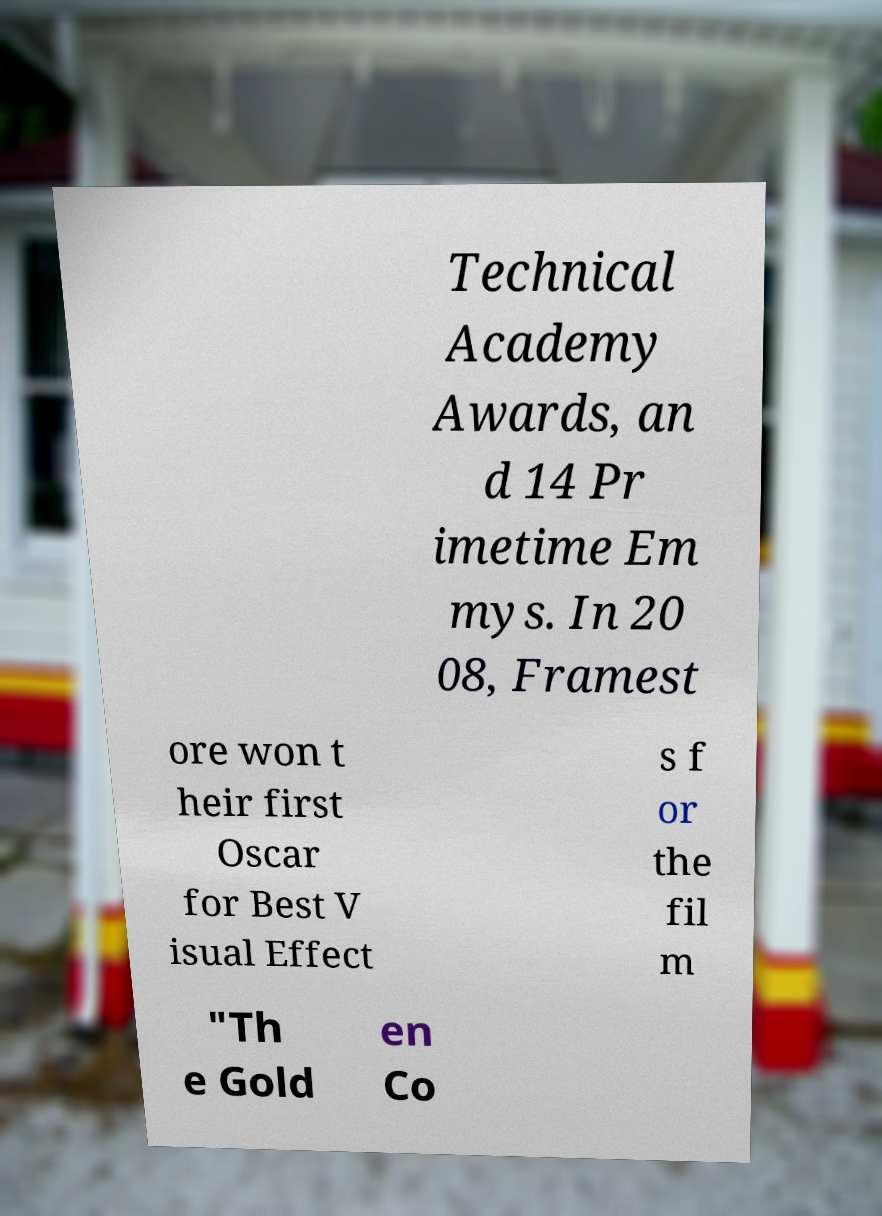I need the written content from this picture converted into text. Can you do that? Technical Academy Awards, an d 14 Pr imetime Em mys. In 20 08, Framest ore won t heir first Oscar for Best V isual Effect s f or the fil m "Th e Gold en Co 